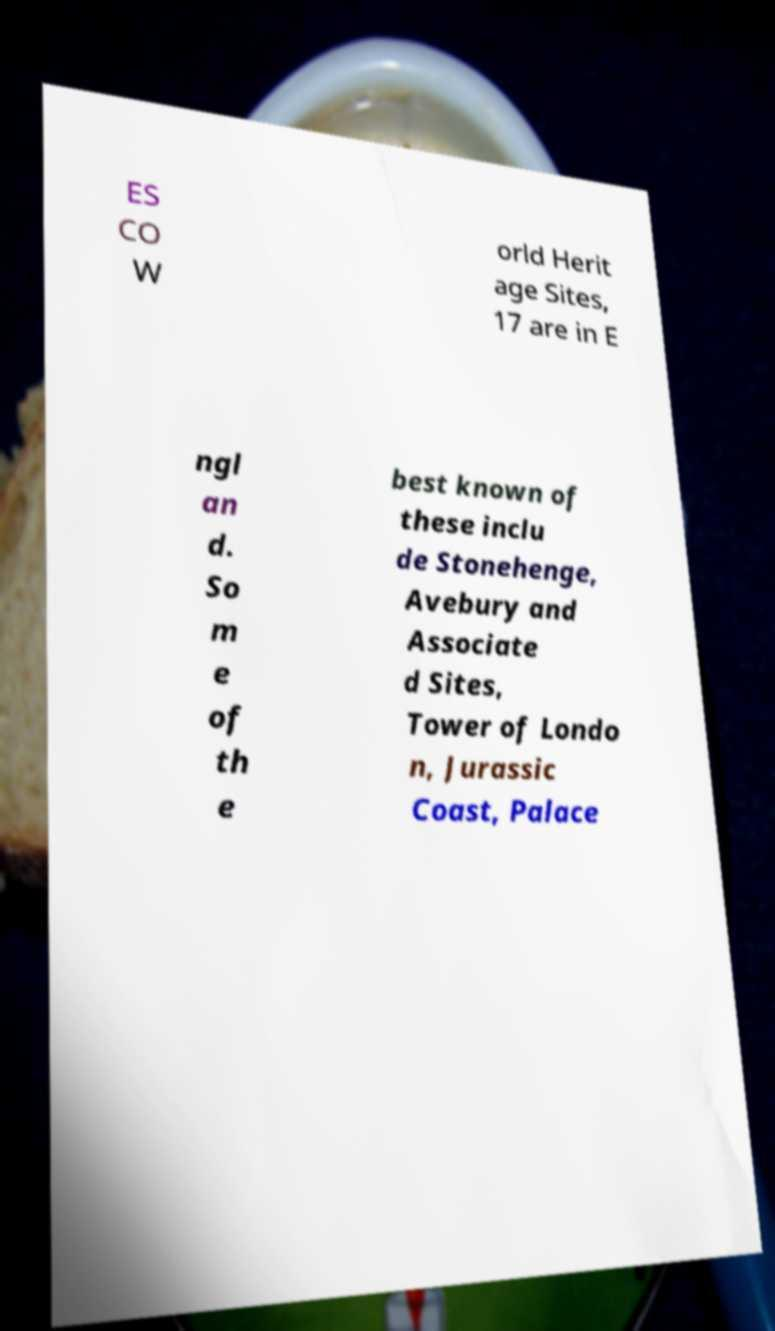For documentation purposes, I need the text within this image transcribed. Could you provide that? ES CO W orld Herit age Sites, 17 are in E ngl an d. So m e of th e best known of these inclu de Stonehenge, Avebury and Associate d Sites, Tower of Londo n, Jurassic Coast, Palace 